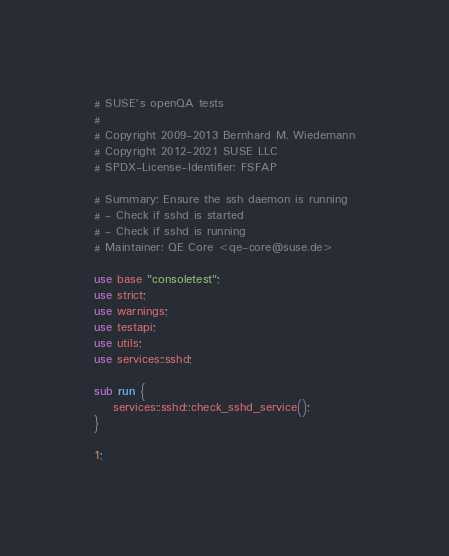Convert code to text. <code><loc_0><loc_0><loc_500><loc_500><_Perl_># SUSE's openQA tests
#
# Copyright 2009-2013 Bernhard M. Wiedemann
# Copyright 2012-2021 SUSE LLC
# SPDX-License-Identifier: FSFAP

# Summary: Ensure the ssh daemon is running
# - Check if sshd is started
# - Check if sshd is running
# Maintainer: QE Core <qe-core@suse.de>

use base "consoletest";
use strict;
use warnings;
use testapi;
use utils;
use services::sshd;

sub run {
    services::sshd::check_sshd_service();
}

1;
</code> 